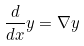<formula> <loc_0><loc_0><loc_500><loc_500>\frac { d } { d x } y = \nabla y</formula> 